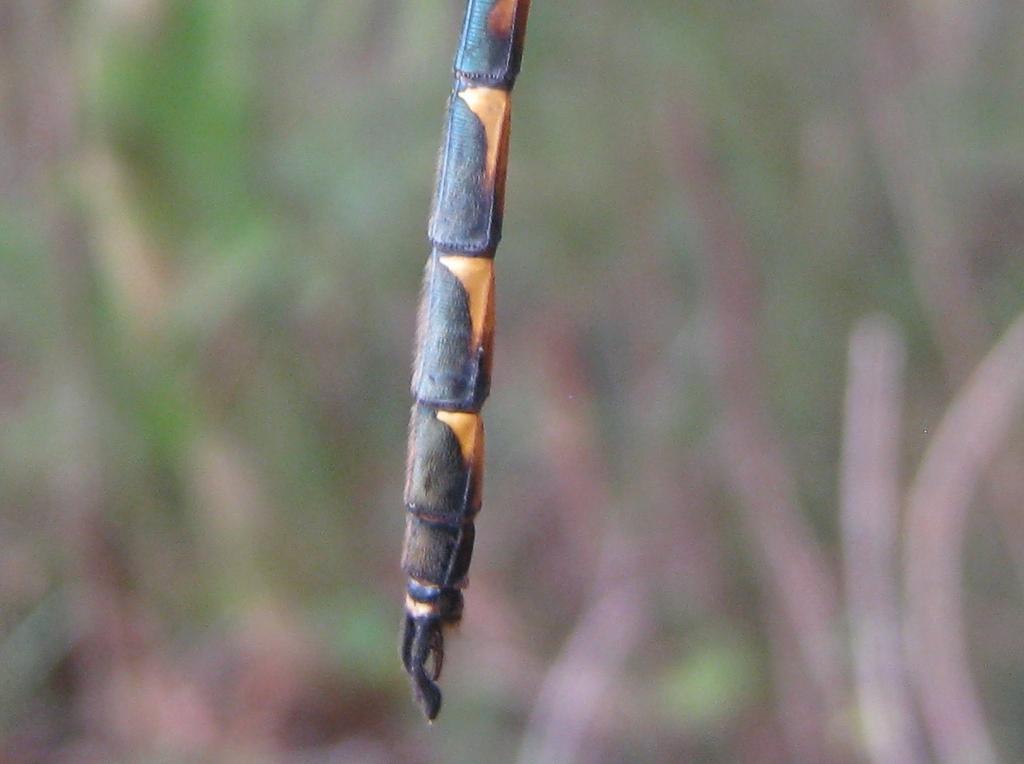In one or two sentences, can you explain what this image depicts? Here there is a insect leg seen in the image. Behind there is a blur background. 